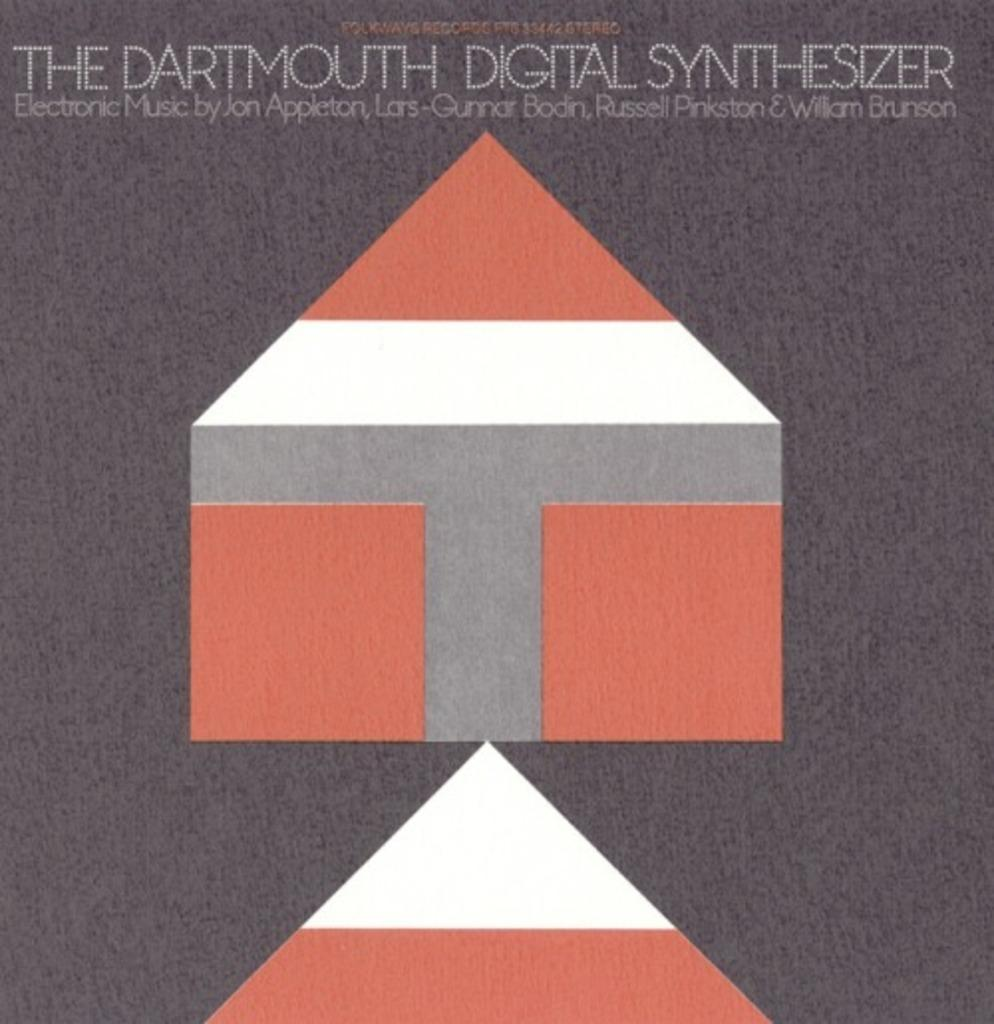<image>
Write a terse but informative summary of the picture. An album with electronic music by Jon Appleton 